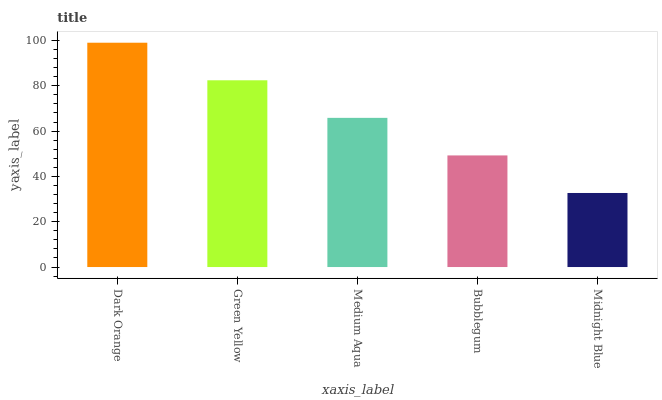Is Midnight Blue the minimum?
Answer yes or no. Yes. Is Dark Orange the maximum?
Answer yes or no. Yes. Is Green Yellow the minimum?
Answer yes or no. No. Is Green Yellow the maximum?
Answer yes or no. No. Is Dark Orange greater than Green Yellow?
Answer yes or no. Yes. Is Green Yellow less than Dark Orange?
Answer yes or no. Yes. Is Green Yellow greater than Dark Orange?
Answer yes or no. No. Is Dark Orange less than Green Yellow?
Answer yes or no. No. Is Medium Aqua the high median?
Answer yes or no. Yes. Is Medium Aqua the low median?
Answer yes or no. Yes. Is Bubblegum the high median?
Answer yes or no. No. Is Dark Orange the low median?
Answer yes or no. No. 